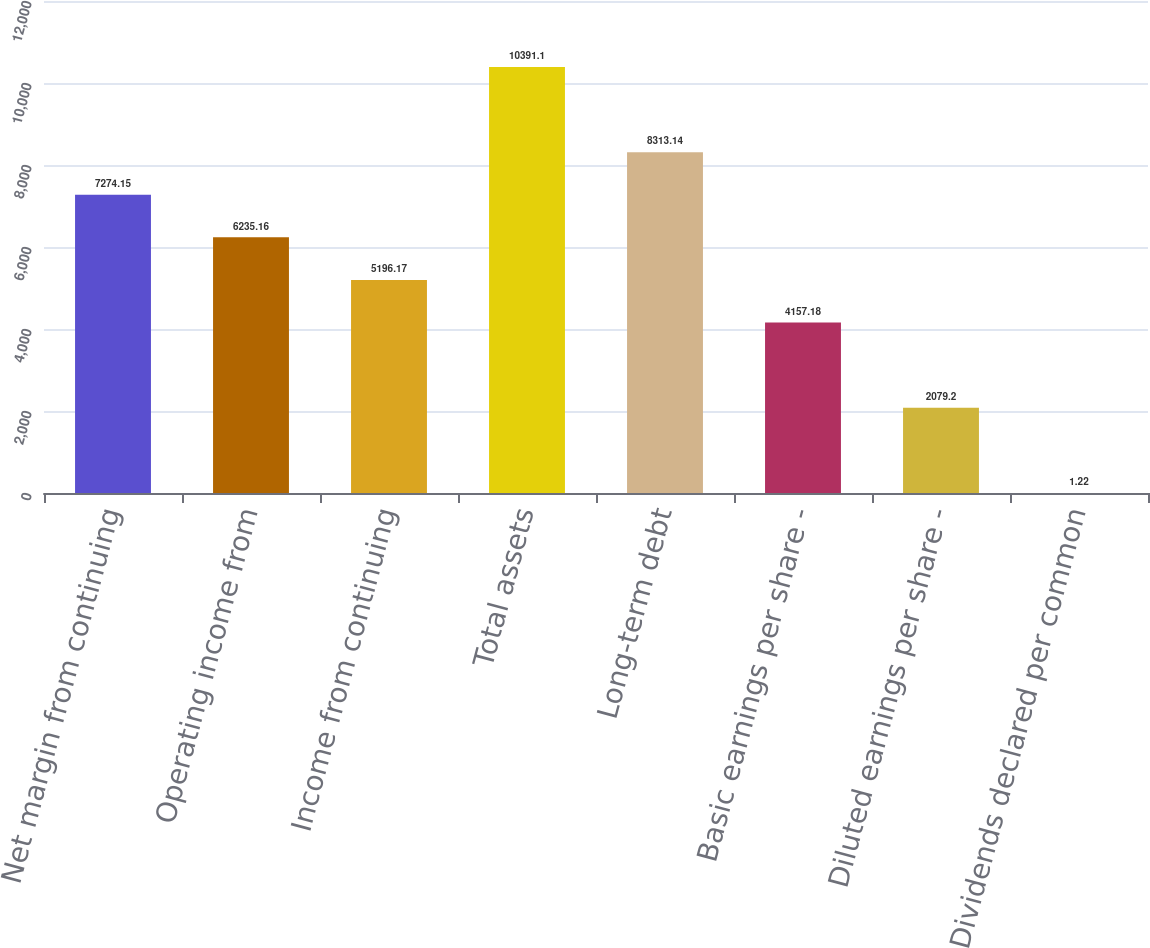Convert chart to OTSL. <chart><loc_0><loc_0><loc_500><loc_500><bar_chart><fcel>Net margin from continuing<fcel>Operating income from<fcel>Income from continuing<fcel>Total assets<fcel>Long-term debt<fcel>Basic earnings per share -<fcel>Diluted earnings per share -<fcel>Dividends declared per common<nl><fcel>7274.15<fcel>6235.16<fcel>5196.17<fcel>10391.1<fcel>8313.14<fcel>4157.18<fcel>2079.2<fcel>1.22<nl></chart> 